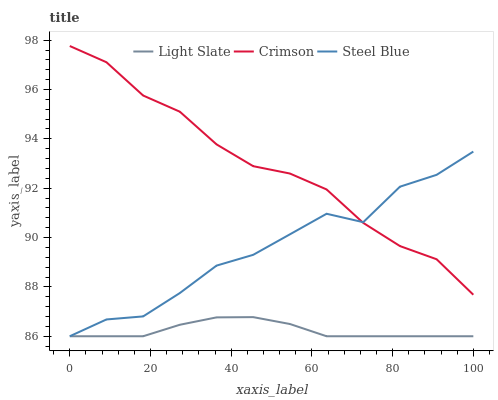Does Light Slate have the minimum area under the curve?
Answer yes or no. Yes. Does Crimson have the maximum area under the curve?
Answer yes or no. Yes. Does Steel Blue have the minimum area under the curve?
Answer yes or no. No. Does Steel Blue have the maximum area under the curve?
Answer yes or no. No. Is Light Slate the smoothest?
Answer yes or no. Yes. Is Steel Blue the roughest?
Answer yes or no. Yes. Is Crimson the smoothest?
Answer yes or no. No. Is Crimson the roughest?
Answer yes or no. No. Does Light Slate have the lowest value?
Answer yes or no. Yes. Does Crimson have the lowest value?
Answer yes or no. No. Does Crimson have the highest value?
Answer yes or no. Yes. Does Steel Blue have the highest value?
Answer yes or no. No. Is Light Slate less than Crimson?
Answer yes or no. Yes. Is Crimson greater than Light Slate?
Answer yes or no. Yes. Does Steel Blue intersect Crimson?
Answer yes or no. Yes. Is Steel Blue less than Crimson?
Answer yes or no. No. Is Steel Blue greater than Crimson?
Answer yes or no. No. Does Light Slate intersect Crimson?
Answer yes or no. No. 